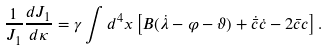Convert formula to latex. <formula><loc_0><loc_0><loc_500><loc_500>\frac { 1 } { J _ { 1 } } \frac { d J _ { 1 } } { d \kappa } = \gamma \int d ^ { 4 } x \left [ B ( \dot { \lambda } - \varphi - \vartheta ) + \dot { \bar { c } } \dot { c } - 2 \bar { c } c \right ] .</formula> 